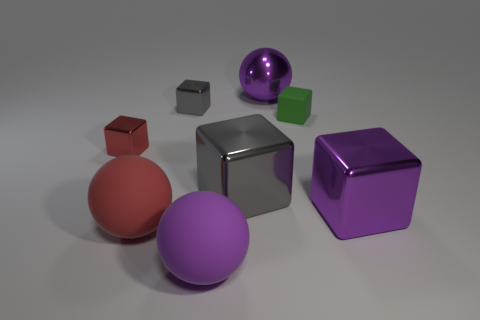There is a rubber thing that is behind the red block; is it the same size as the large purple shiny sphere?
Give a very brief answer. No. What color is the metallic sphere that is the same size as the purple shiny cube?
Make the answer very short. Purple. There is a big purple ball that is in front of the metallic thing that is in front of the big gray object; are there any red rubber spheres that are in front of it?
Ensure brevity in your answer.  No. There is a big object that is behind the small red metallic block; what material is it?
Ensure brevity in your answer.  Metal. Do the tiny green rubber object and the red object that is on the right side of the tiny red cube have the same shape?
Make the answer very short. No. Is the number of large metal objects on the right side of the large purple shiny cube the same as the number of large rubber spheres right of the small gray object?
Your response must be concise. No. How many other things are made of the same material as the red sphere?
Ensure brevity in your answer.  2. What number of metallic objects are either small green blocks or big gray objects?
Offer a very short reply. 1. There is a purple thing that is behind the purple shiny cube; does it have the same shape as the red metallic thing?
Your answer should be compact. No. Is the number of red metal things in front of the green matte thing greater than the number of small blue things?
Your response must be concise. Yes. 